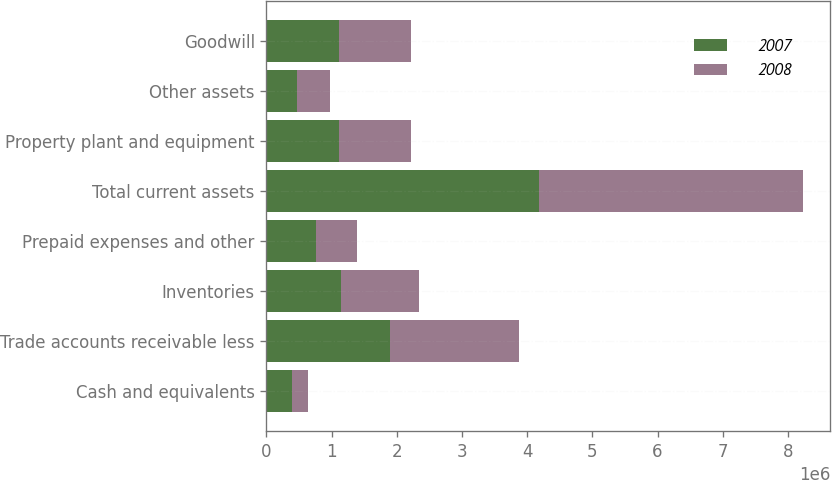Convert chart to OTSL. <chart><loc_0><loc_0><loc_500><loc_500><stacked_bar_chart><ecel><fcel>Cash and equivalents<fcel>Trade accounts receivable less<fcel>Inventories<fcel>Prepaid expenses and other<fcel>Total current assets<fcel>Property plant and equipment<fcel>Other assets<fcel>Goodwill<nl><fcel>2007<fcel>392854<fcel>1.89458e+06<fcel>1.14231e+06<fcel>757371<fcel>4.18712e+06<fcel>1.10865e+06<fcel>464353<fcel>1.10864e+06<nl><fcel>2008<fcel>239108<fcel>1.98438e+06<fcel>1.19362e+06<fcel>632660<fcel>4.04977e+06<fcel>1.10863e+06<fcel>507550<fcel>1.10864e+06<nl></chart> 